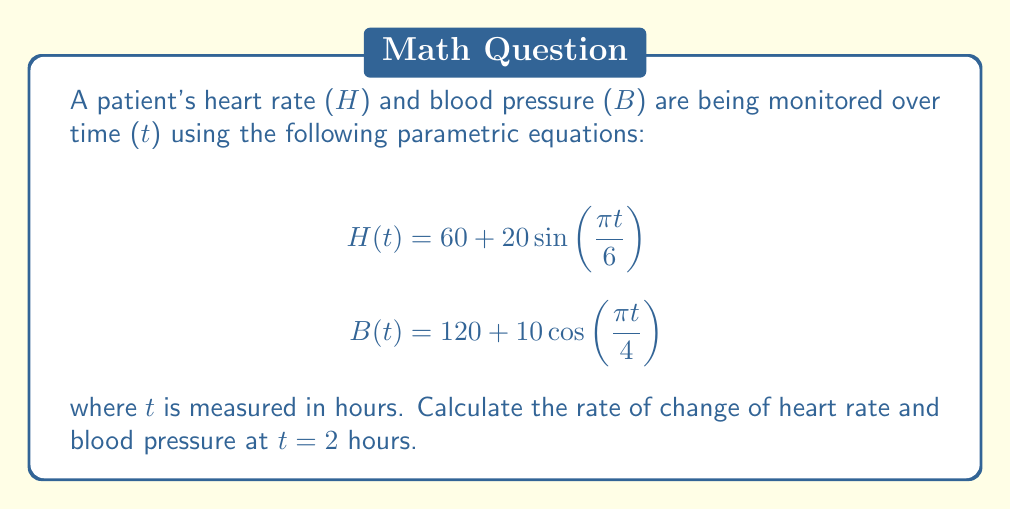Provide a solution to this math problem. To find the rate of change of heart rate and blood pressure at t = 2 hours, we need to calculate the derivatives of H(t) and B(t) with respect to t, then evaluate them at t = 2.

1. For heart rate H(t):
   $$\frac{dH}{dt} = 20 \cdot \frac{\pi}{6} \cos(\frac{\pi t}{6})$$

2. For blood pressure B(t):
   $$\frac{dB}{dt} = -10 \cdot \frac{\pi}{4} \sin(\frac{\pi t}{4})$$

3. Evaluating $\frac{dH}{dt}$ at t = 2:
   $$\frac{dH}{dt}(2) = 20 \cdot \frac{\pi}{6} \cos(\frac{\pi \cdot 2}{6}) = \frac{10\pi}{3} \cos(\frac{\pi}{3}) = \frac{5\pi}{3} \approx 5.24$$

4. Evaluating $\frac{dB}{dt}$ at t = 2:
   $$\frac{dB}{dt}(2) = -10 \cdot \frac{\pi}{4} \sin(\frac{\pi \cdot 2}{4}) = -\frac{5\pi}{2} \sin(\frac{\pi}{2}) = -\frac{5\pi}{2} \approx -7.85$$

The rate of change of heart rate is approximately 5.24 beats per minute per hour, and the rate of change of blood pressure is approximately -7.85 mmHg per hour at t = 2 hours.
Answer: At t = 2 hours:
Rate of change of heart rate ≈ 5.24 beats/min/hour
Rate of change of blood pressure ≈ -7.85 mmHg/hour 